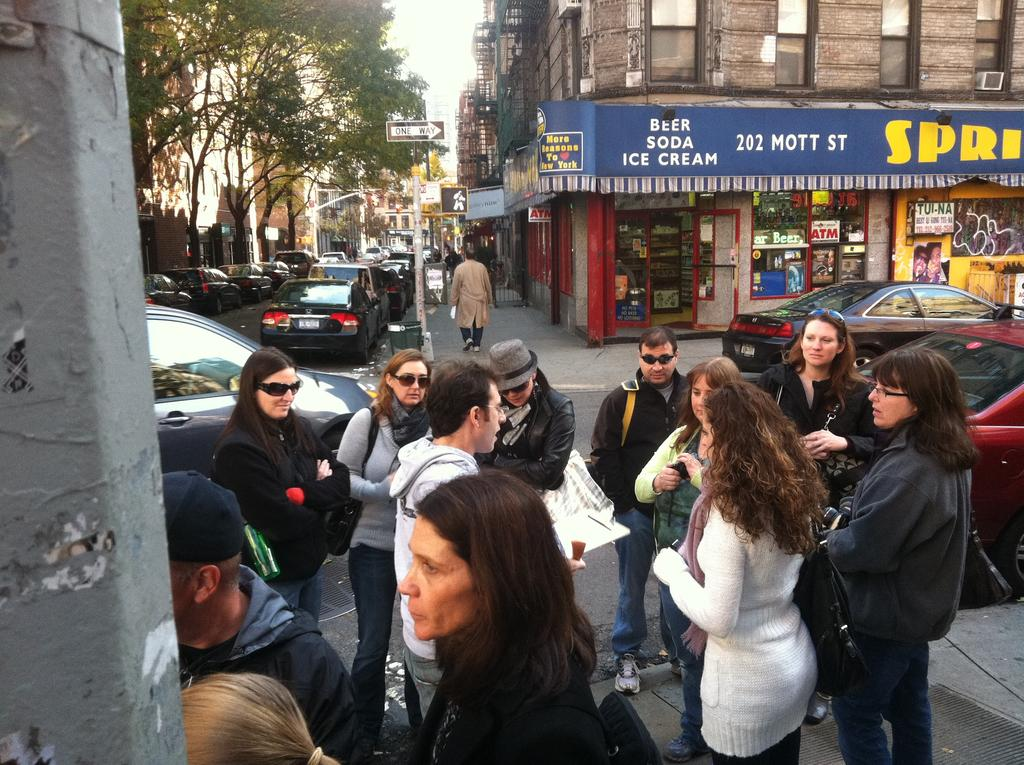What is the main subject of the image? There is a group of people on the ground. What else can be seen in the image besides the people? There are vehicles, buildings, and trees in the image. How many boys are sitting on the can in the image? There is no can present in the image, and therefore no boys can be seen sitting on it. 